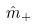<formula> <loc_0><loc_0><loc_500><loc_500>\hat { m } _ { + }</formula> 